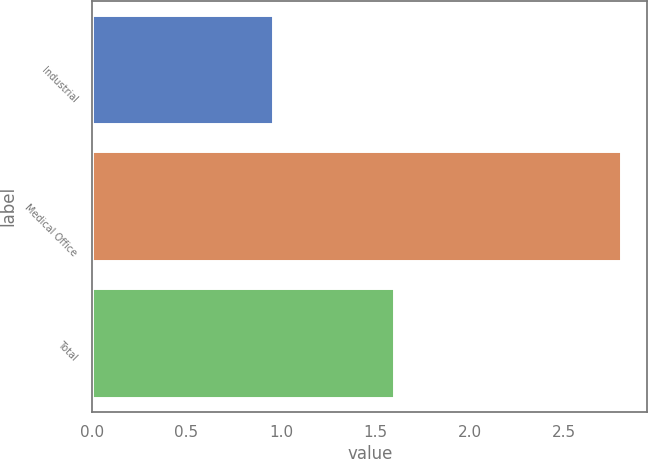Convert chart. <chart><loc_0><loc_0><loc_500><loc_500><bar_chart><fcel>Industrial<fcel>Medical Office<fcel>Total<nl><fcel>0.96<fcel>2.8<fcel>1.6<nl></chart> 